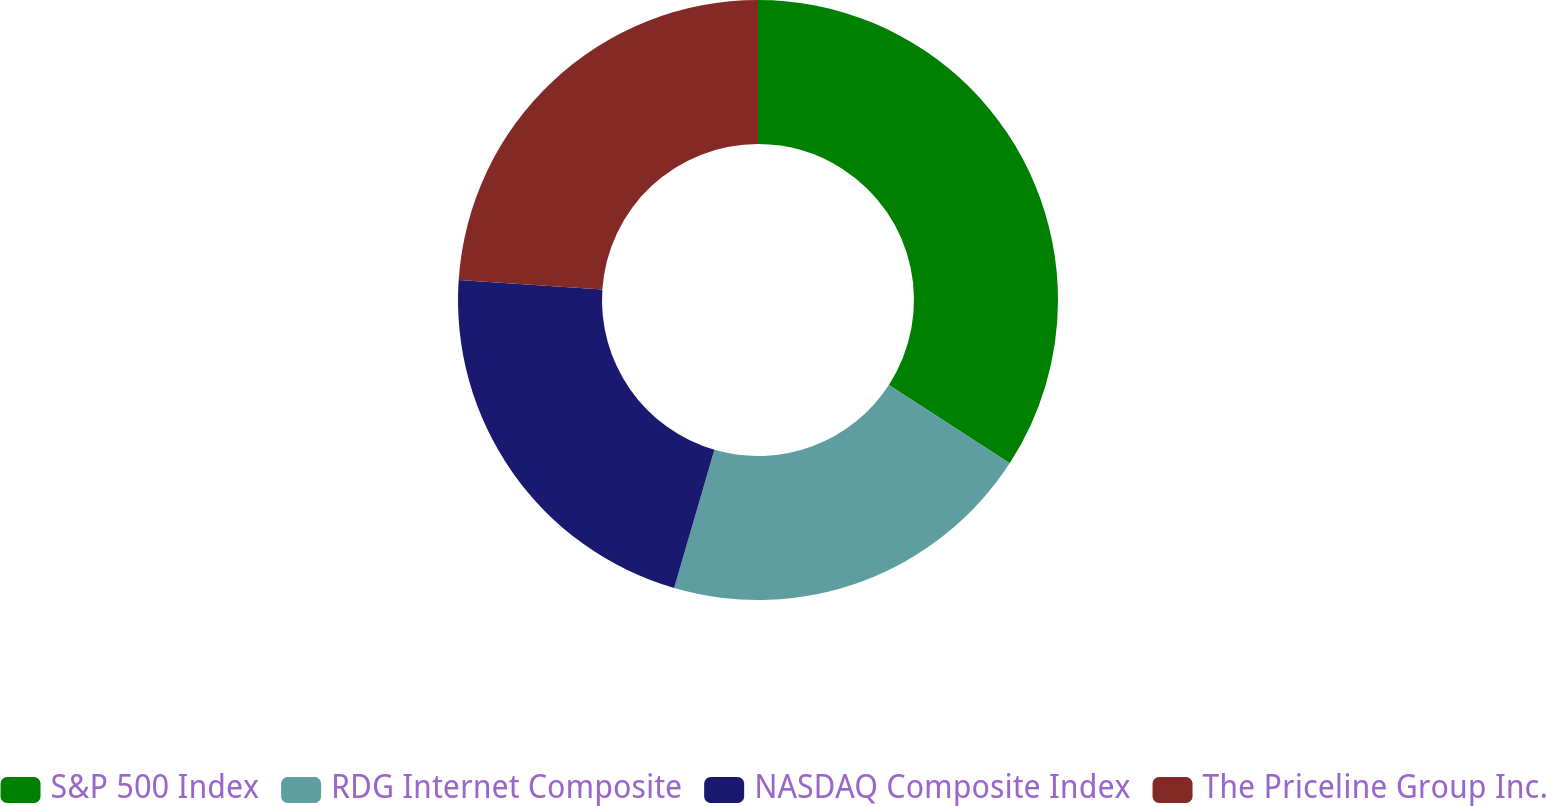Convert chart to OTSL. <chart><loc_0><loc_0><loc_500><loc_500><pie_chart><fcel>S&P 500 Index<fcel>RDG Internet Composite<fcel>NASDAQ Composite Index<fcel>The Priceline Group Inc.<nl><fcel>34.16%<fcel>20.35%<fcel>21.55%<fcel>23.94%<nl></chart> 